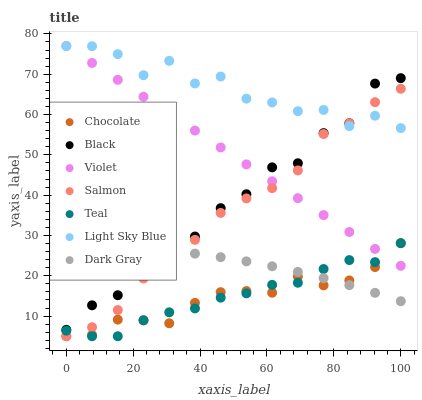Does Chocolate have the minimum area under the curve?
Answer yes or no. Yes. Does Light Sky Blue have the maximum area under the curve?
Answer yes or no. Yes. Does Dark Gray have the minimum area under the curve?
Answer yes or no. No. Does Dark Gray have the maximum area under the curve?
Answer yes or no. No. Is Violet the smoothest?
Answer yes or no. Yes. Is Light Sky Blue the roughest?
Answer yes or no. Yes. Is Chocolate the smoothest?
Answer yes or no. No. Is Chocolate the roughest?
Answer yes or no. No. Does Salmon have the lowest value?
Answer yes or no. Yes. Does Dark Gray have the lowest value?
Answer yes or no. No. Does Violet have the highest value?
Answer yes or no. Yes. Does Chocolate have the highest value?
Answer yes or no. No. Is Teal less than Light Sky Blue?
Answer yes or no. Yes. Is Violet greater than Dark Gray?
Answer yes or no. Yes. Does Light Sky Blue intersect Salmon?
Answer yes or no. Yes. Is Light Sky Blue less than Salmon?
Answer yes or no. No. Is Light Sky Blue greater than Salmon?
Answer yes or no. No. Does Teal intersect Light Sky Blue?
Answer yes or no. No. 